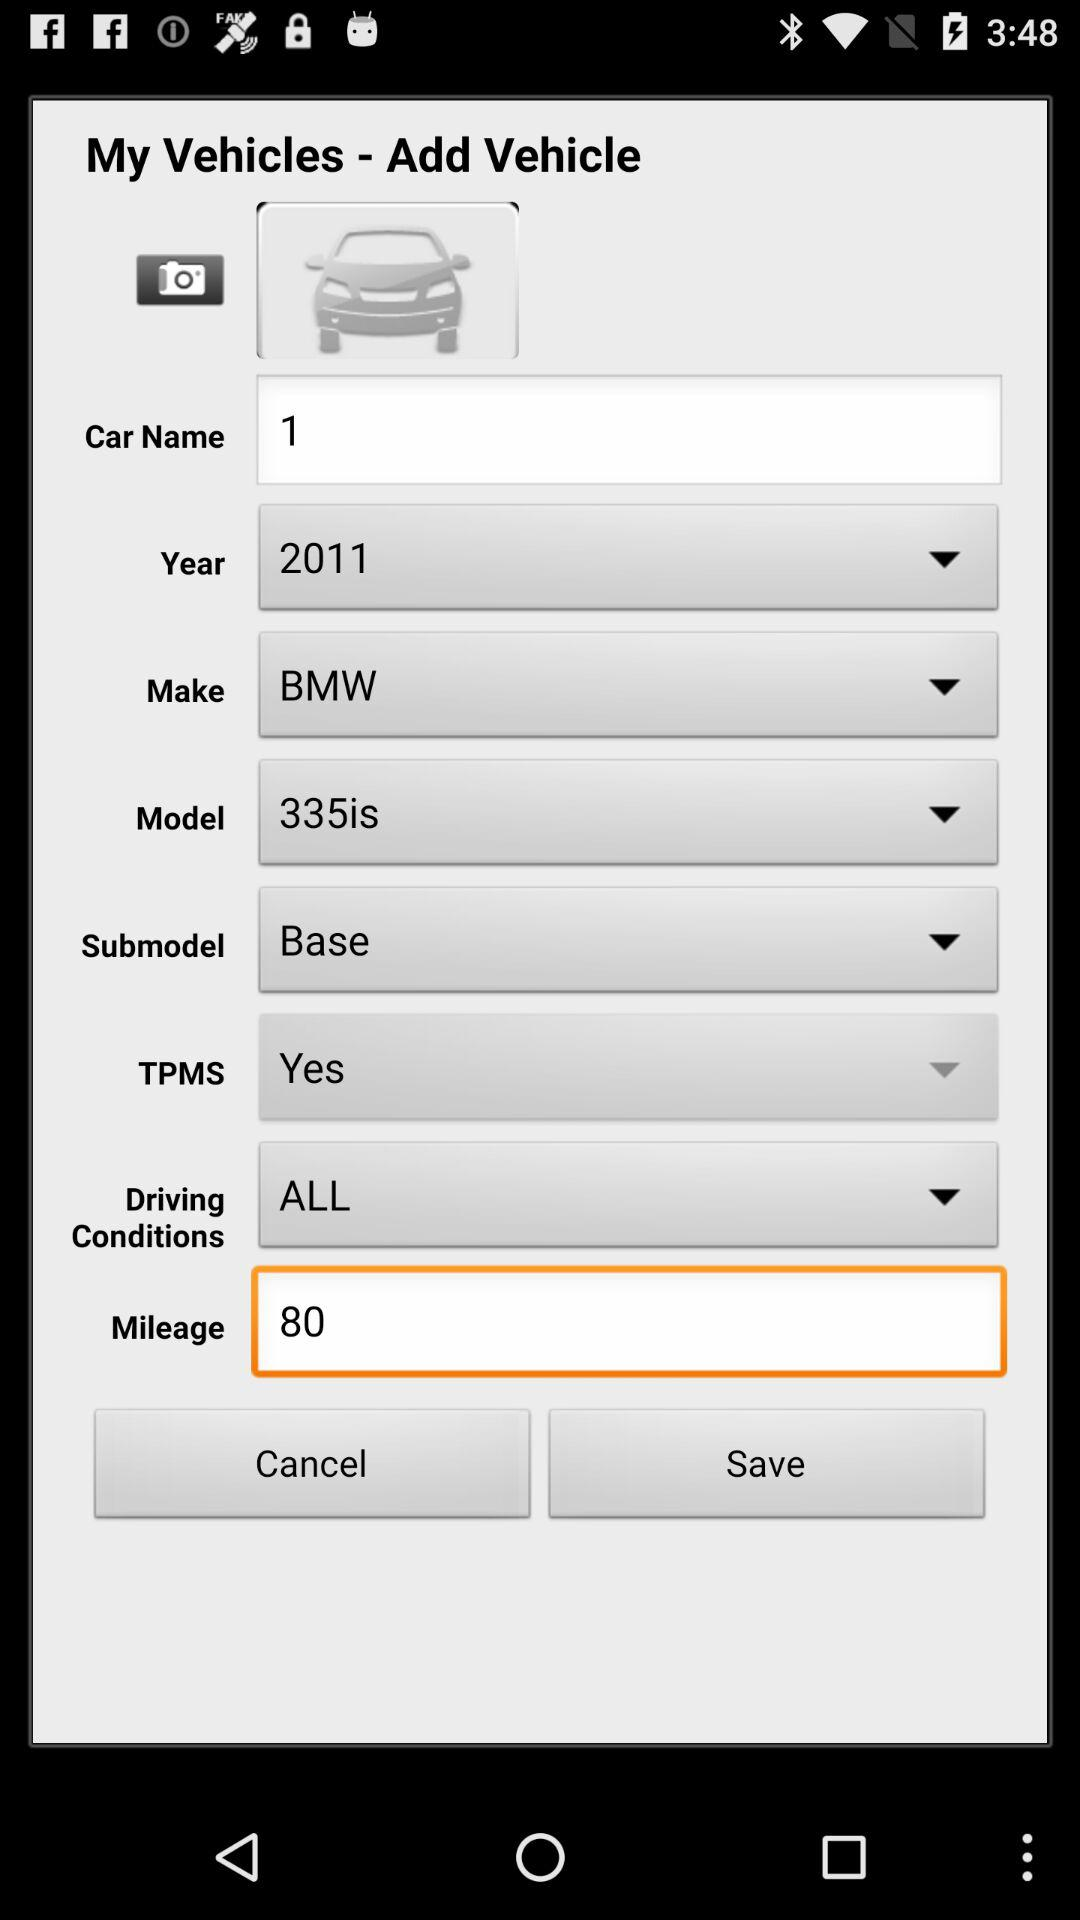Who is the manufacturer of the car? The manufacturer of the car is BMW. 